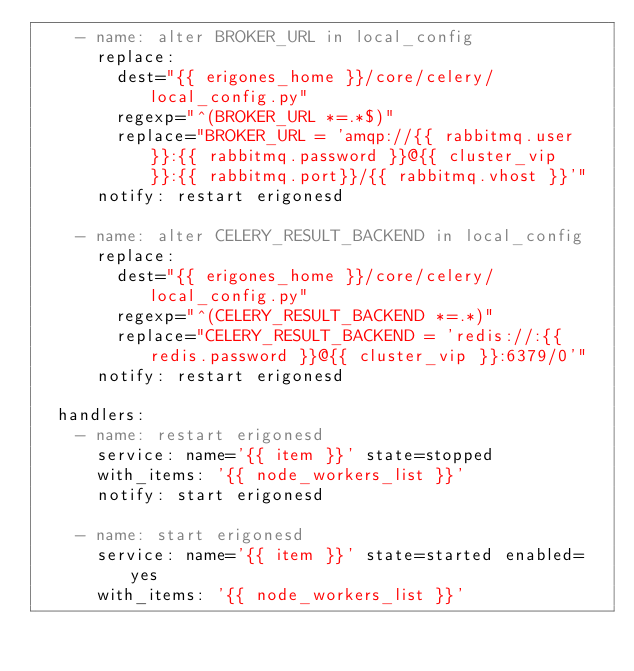<code> <loc_0><loc_0><loc_500><loc_500><_YAML_>    - name: alter BROKER_URL in local_config
      replace:
        dest="{{ erigones_home }}/core/celery/local_config.py"
        regexp="^(BROKER_URL *=.*$)"
        replace="BROKER_URL = 'amqp://{{ rabbitmq.user }}:{{ rabbitmq.password }}@{{ cluster_vip }}:{{ rabbitmq.port}}/{{ rabbitmq.vhost }}'"
      notify: restart erigonesd

    - name: alter CELERY_RESULT_BACKEND in local_config
      replace:
        dest="{{ erigones_home }}/core/celery/local_config.py"
        regexp="^(CELERY_RESULT_BACKEND *=.*)"
        replace="CELERY_RESULT_BACKEND = 'redis://:{{ redis.password }}@{{ cluster_vip }}:6379/0'"
      notify: restart erigonesd

  handlers:
    - name: restart erigonesd
      service: name='{{ item }}' state=stopped
      with_items: '{{ node_workers_list }}'
      notify: start erigonesd

    - name: start erigonesd
      service: name='{{ item }}' state=started enabled=yes
      with_items: '{{ node_workers_list }}'
</code> 